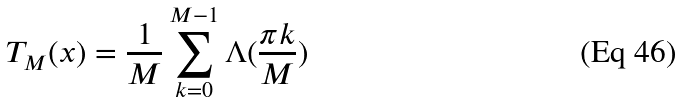<formula> <loc_0><loc_0><loc_500><loc_500>T _ { M } ( x ) = \frac { 1 } { M } \sum _ { k = 0 } ^ { M - 1 } \Lambda ( \frac { \pi k } { M } )</formula> 